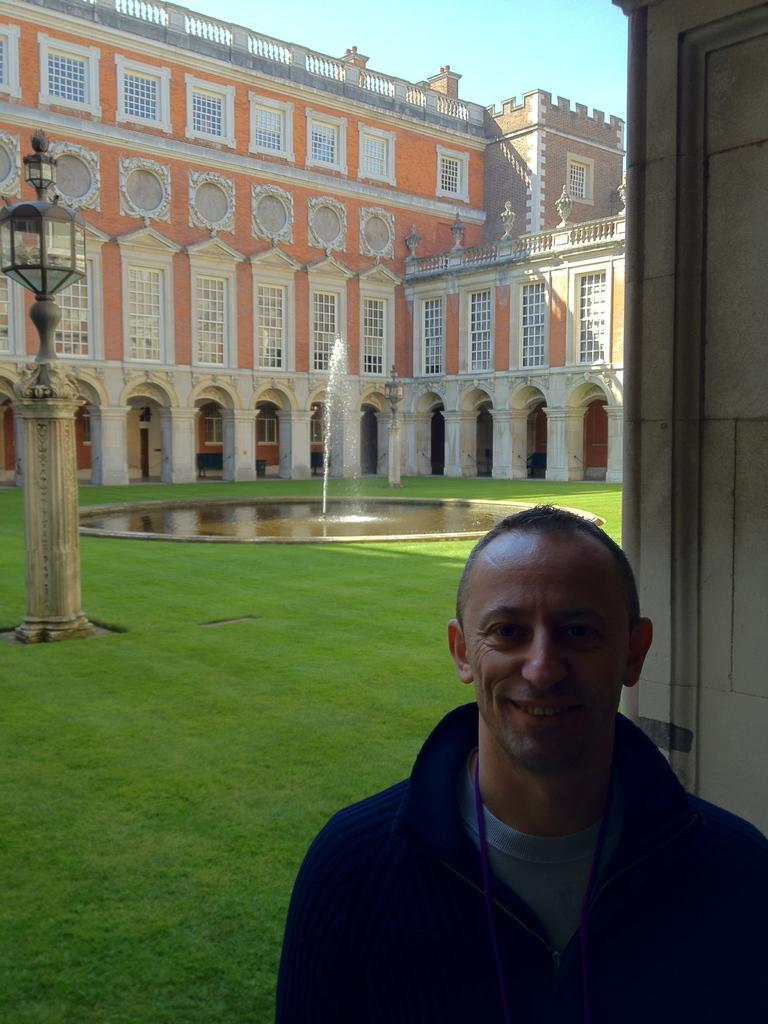How would you summarize this image in a sentence or two? In this image, we can see a person wearing clothes. There is a pole on the left side of the image. There is a fountains in front of the building. There is a sky at the top of the image. 